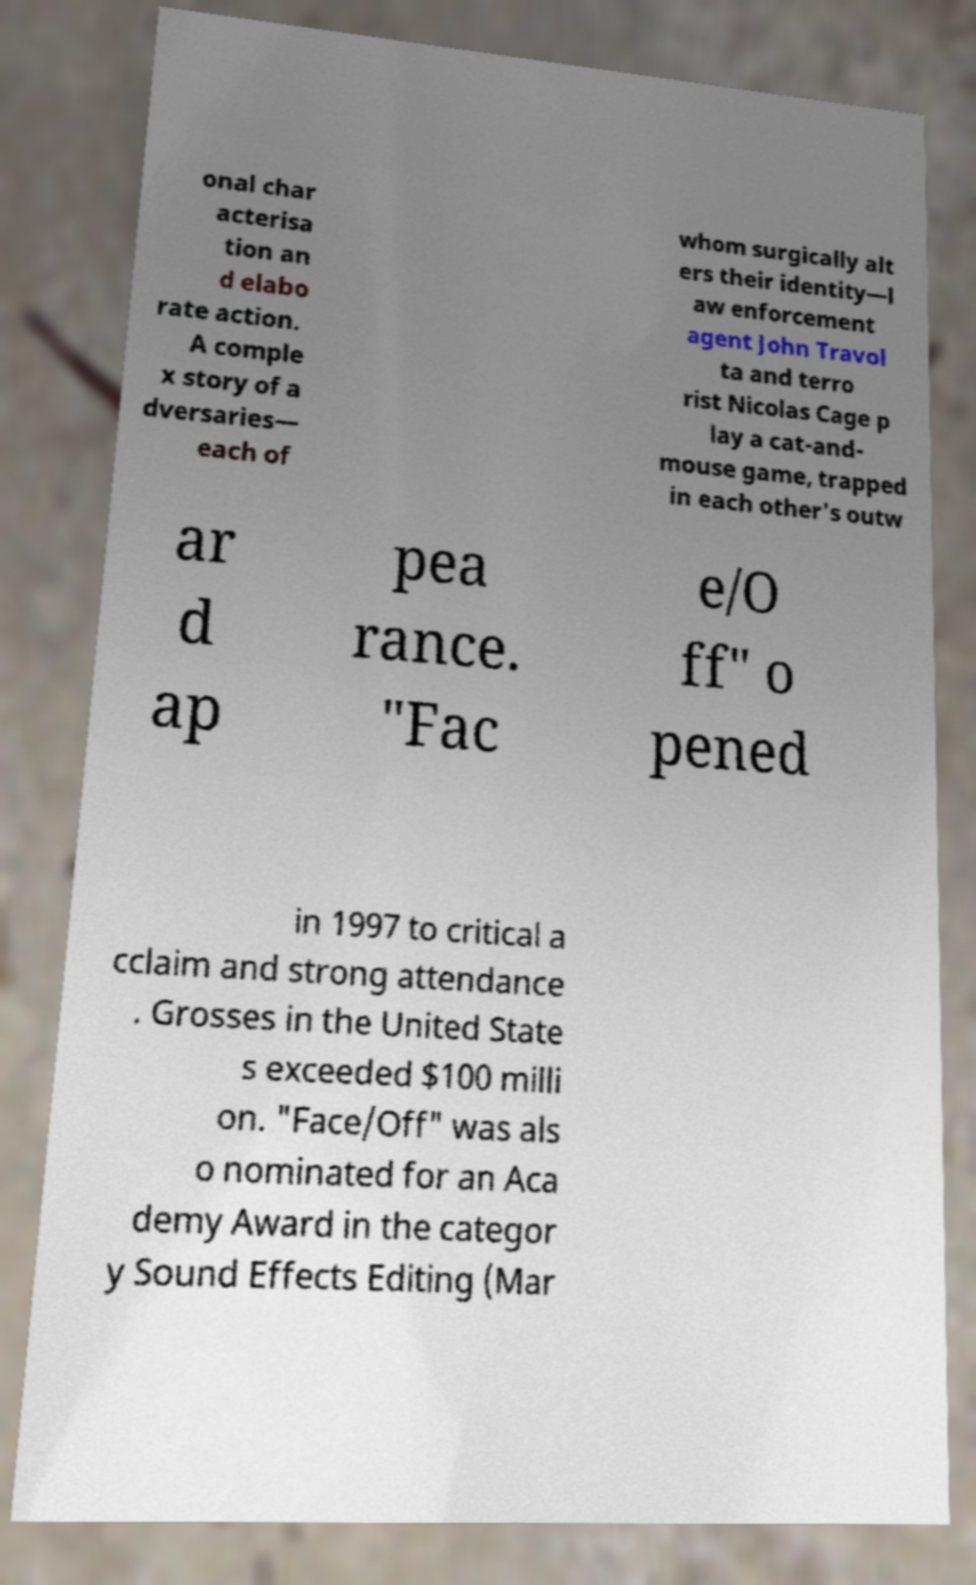Could you assist in decoding the text presented in this image and type it out clearly? onal char acterisa tion an d elabo rate action. A comple x story of a dversaries— each of whom surgically alt ers their identity—l aw enforcement agent John Travol ta and terro rist Nicolas Cage p lay a cat-and- mouse game, trapped in each other's outw ar d ap pea rance. "Fac e/O ff" o pened in 1997 to critical a cclaim and strong attendance . Grosses in the United State s exceeded $100 milli on. "Face/Off" was als o nominated for an Aca demy Award in the categor y Sound Effects Editing (Mar 